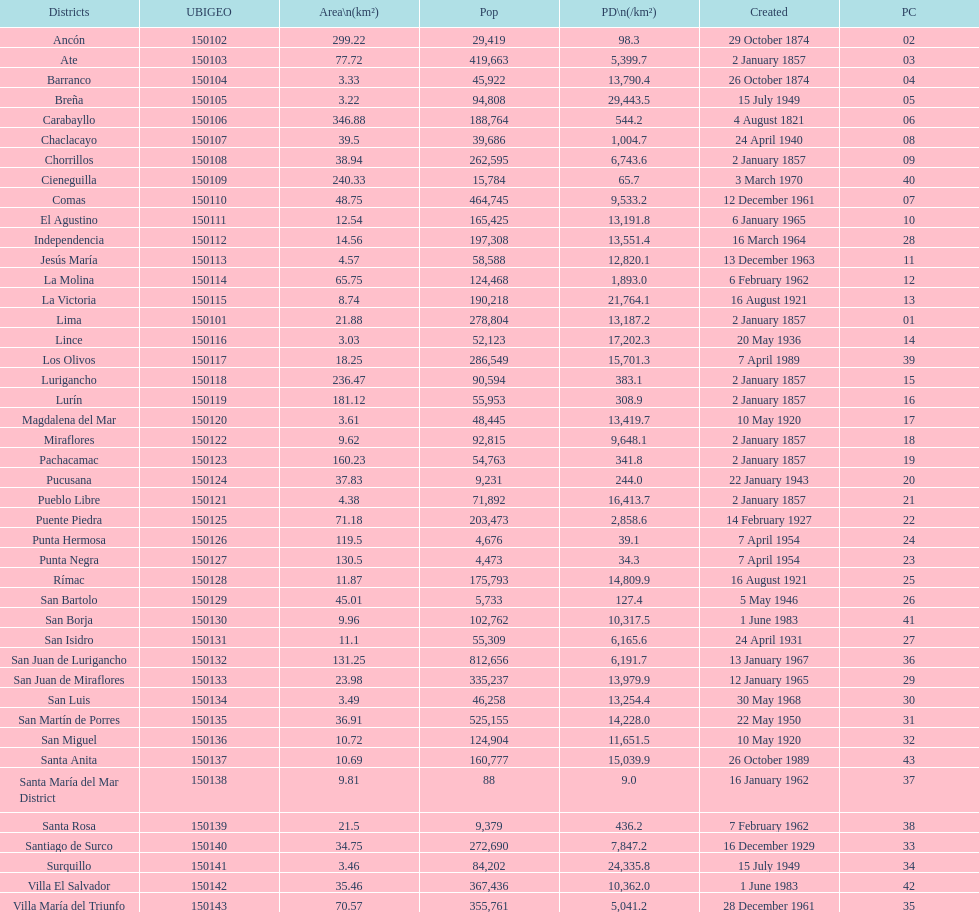How many districts have more than 100,000 people in this city? 21. 